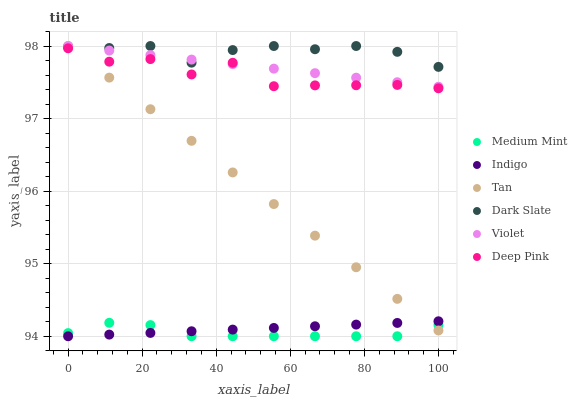Does Medium Mint have the minimum area under the curve?
Answer yes or no. Yes. Does Dark Slate have the maximum area under the curve?
Answer yes or no. Yes. Does Deep Pink have the minimum area under the curve?
Answer yes or no. No. Does Deep Pink have the maximum area under the curve?
Answer yes or no. No. Is Violet the smoothest?
Answer yes or no. Yes. Is Deep Pink the roughest?
Answer yes or no. Yes. Is Indigo the smoothest?
Answer yes or no. No. Is Indigo the roughest?
Answer yes or no. No. Does Medium Mint have the lowest value?
Answer yes or no. Yes. Does Deep Pink have the lowest value?
Answer yes or no. No. Does Tan have the highest value?
Answer yes or no. Yes. Does Deep Pink have the highest value?
Answer yes or no. No. Is Medium Mint less than Dark Slate?
Answer yes or no. Yes. Is Deep Pink greater than Medium Mint?
Answer yes or no. Yes. Does Dark Slate intersect Tan?
Answer yes or no. Yes. Is Dark Slate less than Tan?
Answer yes or no. No. Is Dark Slate greater than Tan?
Answer yes or no. No. Does Medium Mint intersect Dark Slate?
Answer yes or no. No. 